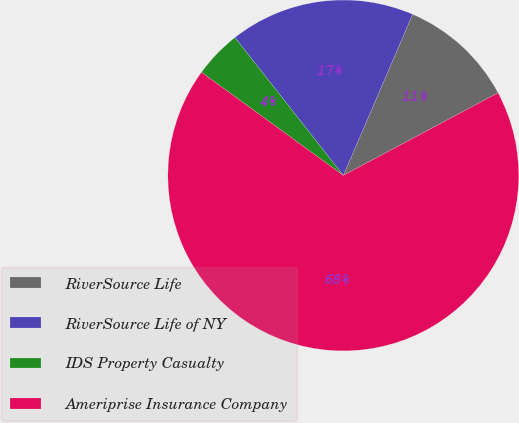Convert chart to OTSL. <chart><loc_0><loc_0><loc_500><loc_500><pie_chart><fcel>RiverSource Life<fcel>RiverSource Life of NY<fcel>IDS Property Casualty<fcel>Ameriprise Insurance Company<nl><fcel>10.73%<fcel>17.07%<fcel>4.39%<fcel>67.81%<nl></chart> 